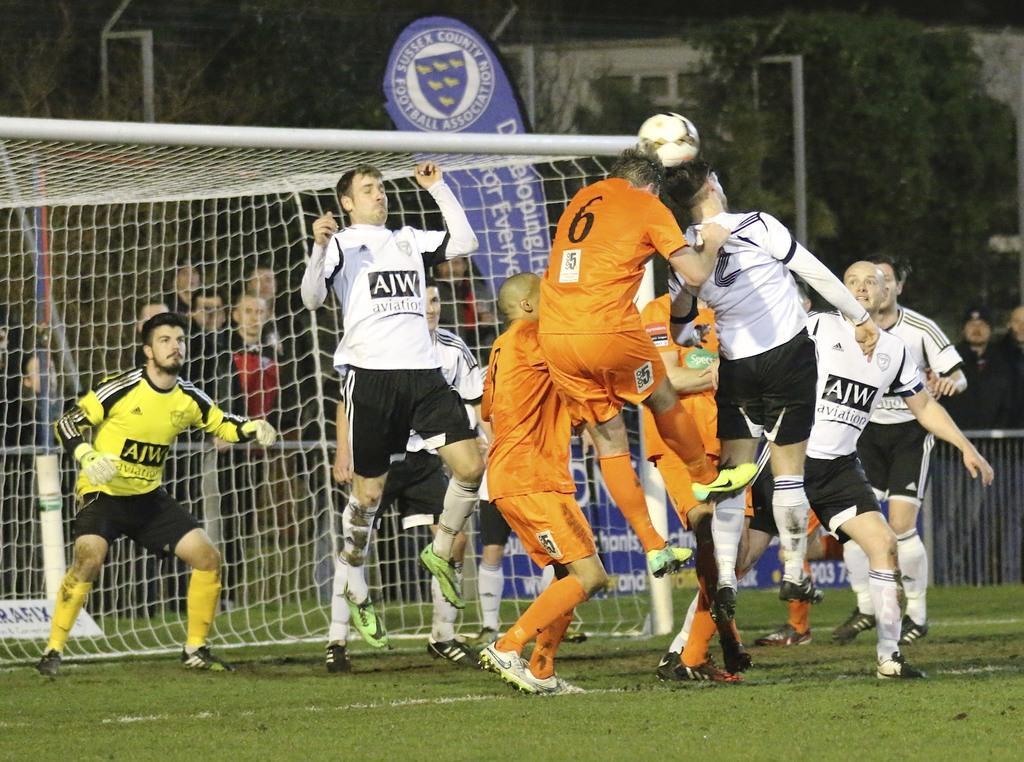Can you describe this image briefly? On the background we can see windows , trees. This is a hoarding board. We can see persons playing with a ball in a playground. This is a net. 